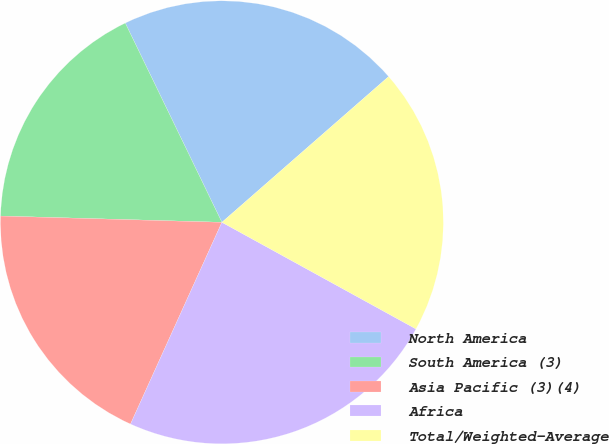Convert chart. <chart><loc_0><loc_0><loc_500><loc_500><pie_chart><fcel>North America<fcel>South America (3)<fcel>Asia Pacific (3)(4)<fcel>Africa<fcel>Total/Weighted-Average<nl><fcel>20.75%<fcel>17.36%<fcel>18.68%<fcel>23.77%<fcel>19.43%<nl></chart> 